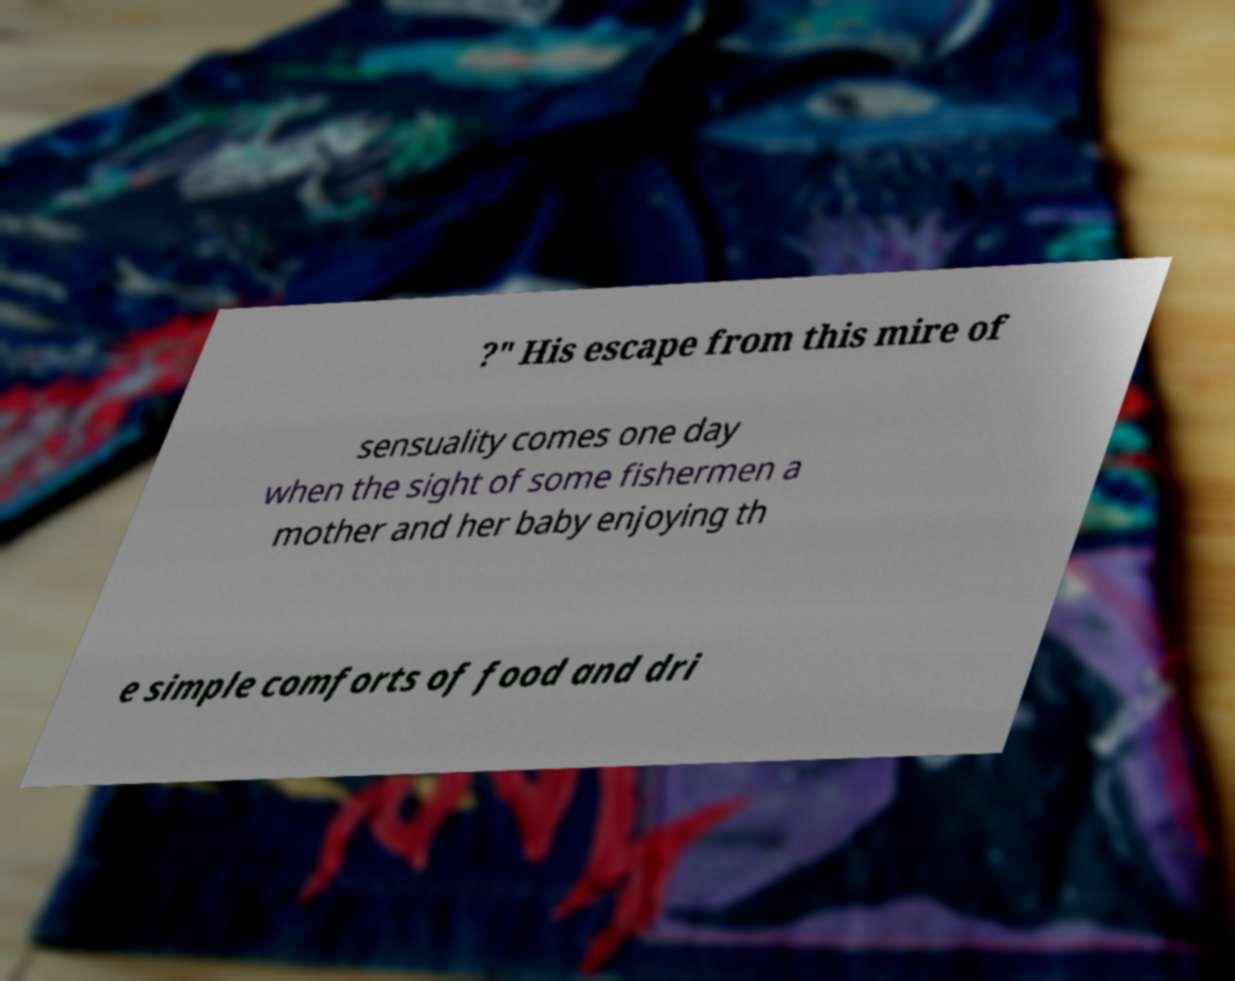There's text embedded in this image that I need extracted. Can you transcribe it verbatim? ?" His escape from this mire of sensuality comes one day when the sight of some fishermen a mother and her baby enjoying th e simple comforts of food and dri 